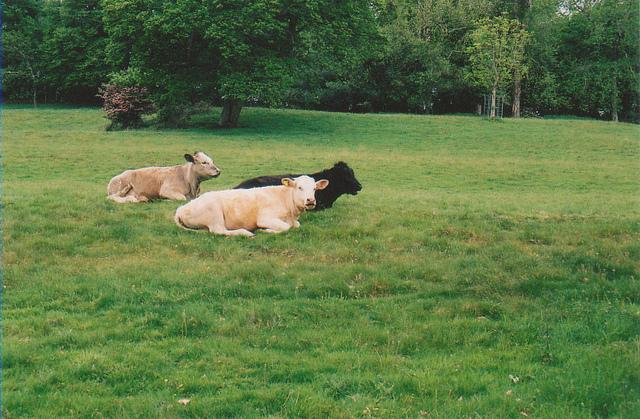What are the cows doing? laying 